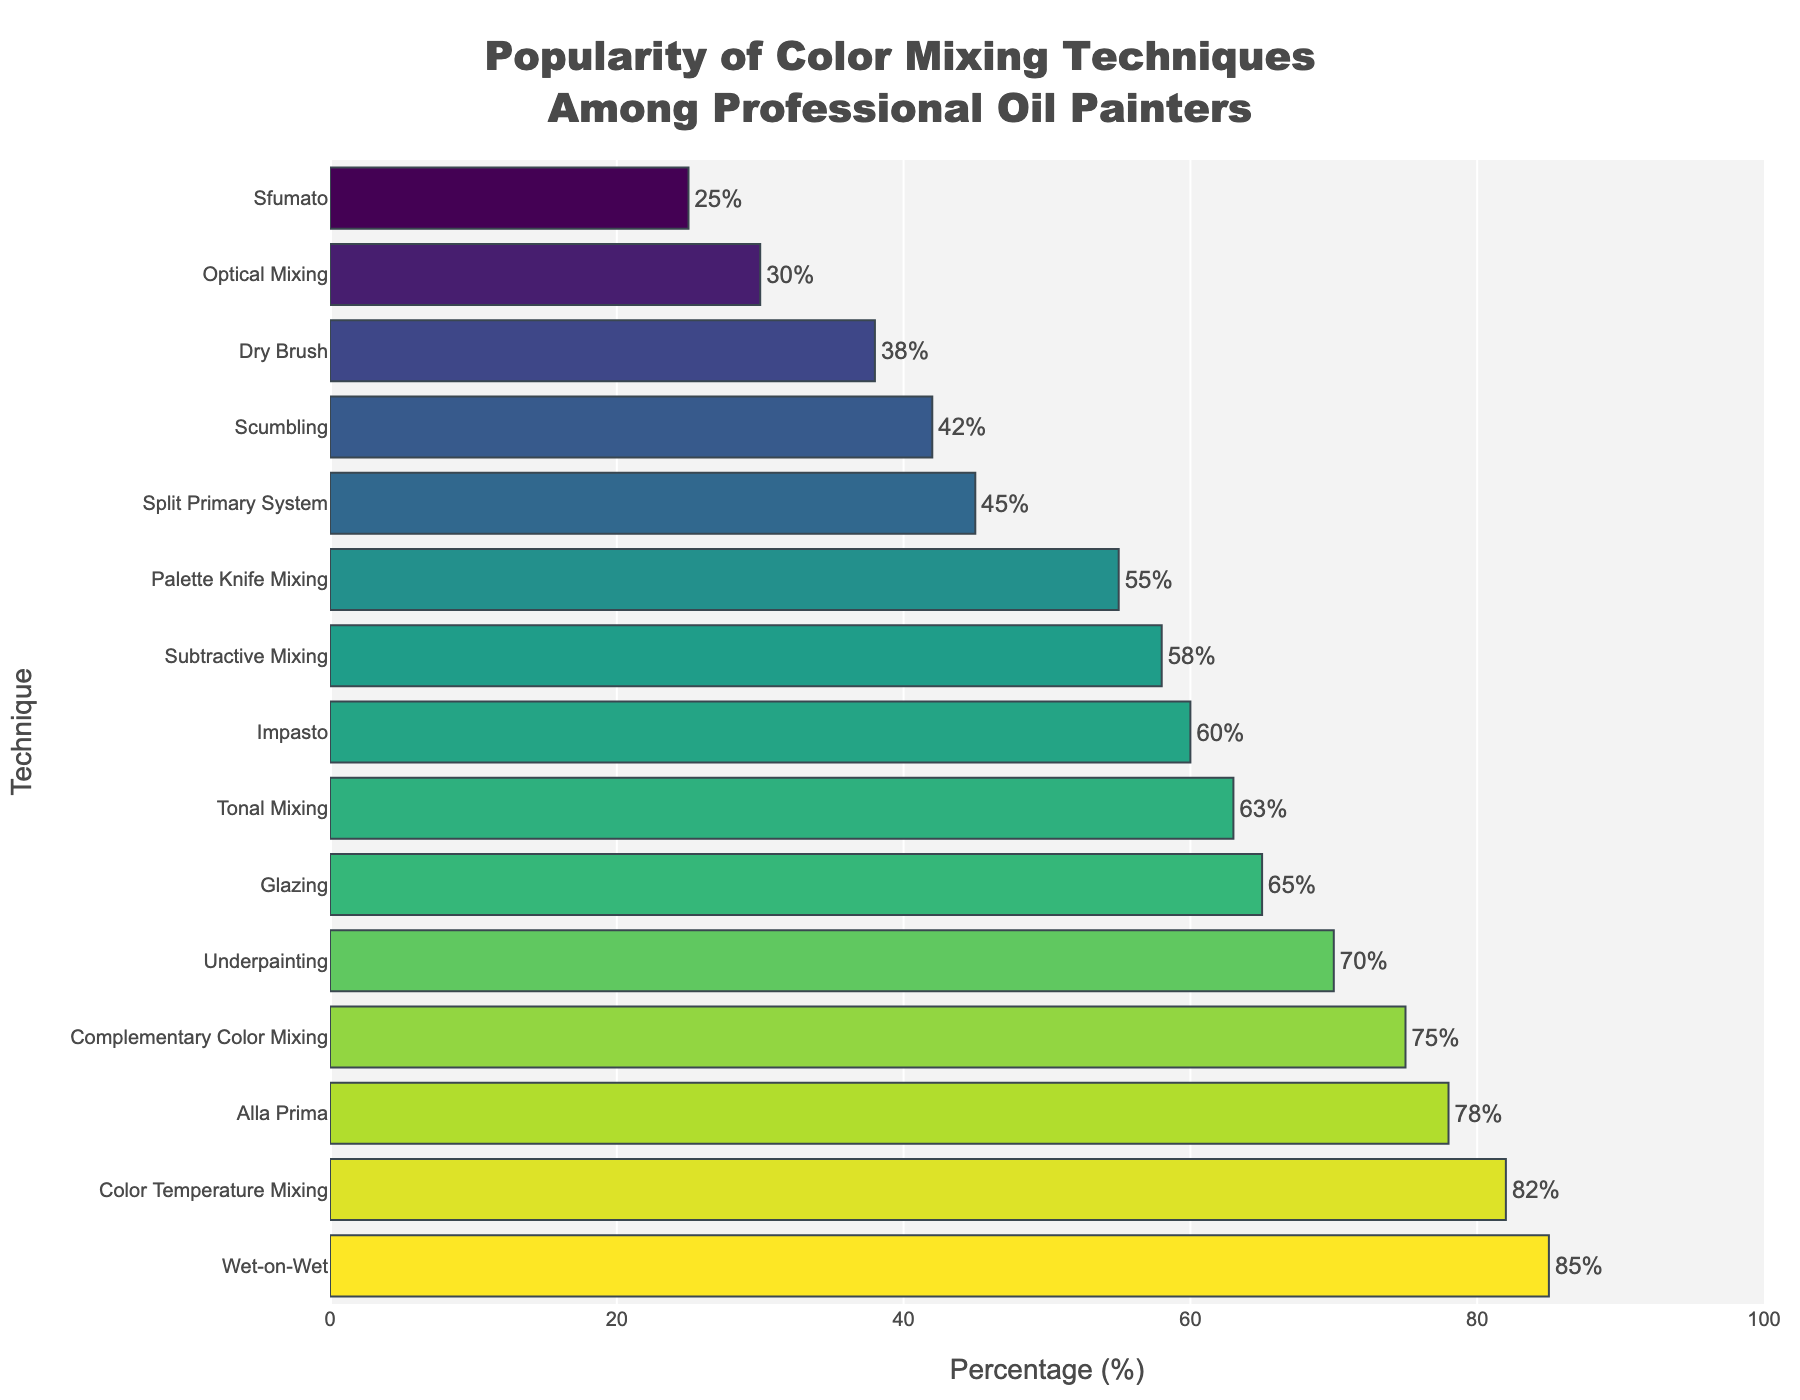Which color mixing technique is the most popular among professional oil painters? By examining the bar chart, we look for the bar that is the longest or reaches the highest percentage on the x-axis. The technique "Wet-on-Wet" has the highest bar at 85%.
Answer: Wet-on-Wet What is the percentage difference between "Underpainting" and "Scumbling"? We find the percentage values for both "Underpainting" (70%) and "Scumbling" (42%) on the chart. Then we subtract the smaller percentage from the larger one: 70% - 42% = 28%.
Answer: 28% How many techniques exceed a 60% popularity? We count the number of bars that stretch beyond the 60% mark on the x-axis: "Wet-on-Wet", "Color Temperature Mixing", "Alla Prima", "Complementary Color Mixing", "Underpainting", and "Glazing" each exceed 60%.
Answer: 6 Which technique has a closest popularity to 50%? We locate the bars around the 50% mark. "Palette Knife Mixing" at 55% and "Split Primary System" at 45% are close, but 55% is nearest to 50%.
Answer: Palette Knife Mixing Is "Impasto" more popular than "Subtractive Mixing"? We compare the heights of the bars for "Impasto" (60%) and "Subtractive Mixing" (58%). Since 60% is greater than 58%, "Impasto" is more popular.
Answer: Yes Which techniques show a popularity percentage between 40% and 70%? We identify bars that fall within the 40% to 70% range on the x-axis: "Scumbling" (42%), "Optical Mixing" (30%), "Subtractive Mixing" (58%), "Split Primary System" (45%), and "Tonal Mixing" (63%), and "Impasto" (60%) meet this criterion.
Answer: Scumbling, Impasto, Subtractive Mixing, Split Primary System, Tonal Mixing What is the average popularity percentage of "Complementary Color Mixing", "Underpainting", and "Palette Knife Mixing"? We sum the percentages for these techniques: 75% (Complementary Color Mixing) + 70% (Underpainting) + 55% (Palette Knife Mixing) = 200%. Then, divide the sum by the number of techniques (3): 200% / 3 = ~66.7%.
Answer: ~66.7% Does "Dry Brush" have less popularity than "Split Primary System"? We compare the heights of the bars for "Dry Brush" (38%) and "Split Primary System" (45%). Since 38% is less than 45%, "Dry Brush" is less popular.
Answer: Yes What is the popularity trend among the top three most popular techniques? We observe the heights of the bars corresponding to the top three techniques: "Wet-on-Wet" (85%), "Color Temperature Mixing" (82%), and "Alla Prima" (78%). The trend shows a slight decrease in popularity as we move from the most popular to the third most popular technique.
Answer: Decreasing How much more popular is "Alla Prima" compared to "Sfumato"? We find the percentage values for both "Alla Prima" (78%) and "Sfumato" (25%) in the chart. Subtract the smaller percentage from the larger one: 78% - 25% = 53%.
Answer: 53% 